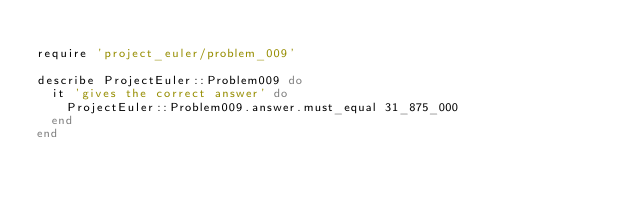<code> <loc_0><loc_0><loc_500><loc_500><_Ruby_>
require 'project_euler/problem_009'

describe ProjectEuler::Problem009 do
  it 'gives the correct answer' do
    ProjectEuler::Problem009.answer.must_equal 31_875_000
  end
end
</code> 